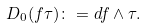<formula> <loc_0><loc_0><loc_500><loc_500>D _ { 0 } ( f \tau ) \colon = d f \wedge \tau .</formula> 